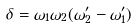<formula> <loc_0><loc_0><loc_500><loc_500>\delta = \omega _ { 1 } \omega _ { 2 } ( \omega _ { 2 } ^ { \prime } - \omega _ { 1 } ^ { \prime } )</formula> 